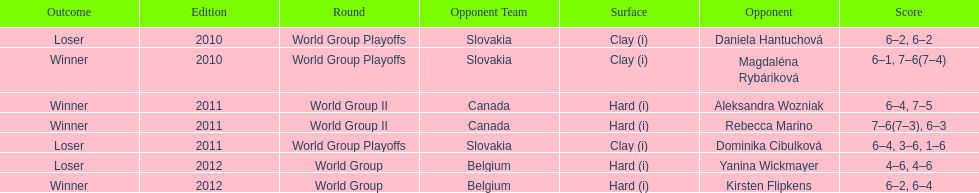In the match with dominika cibulkova, what was the total number of games played? 3. 